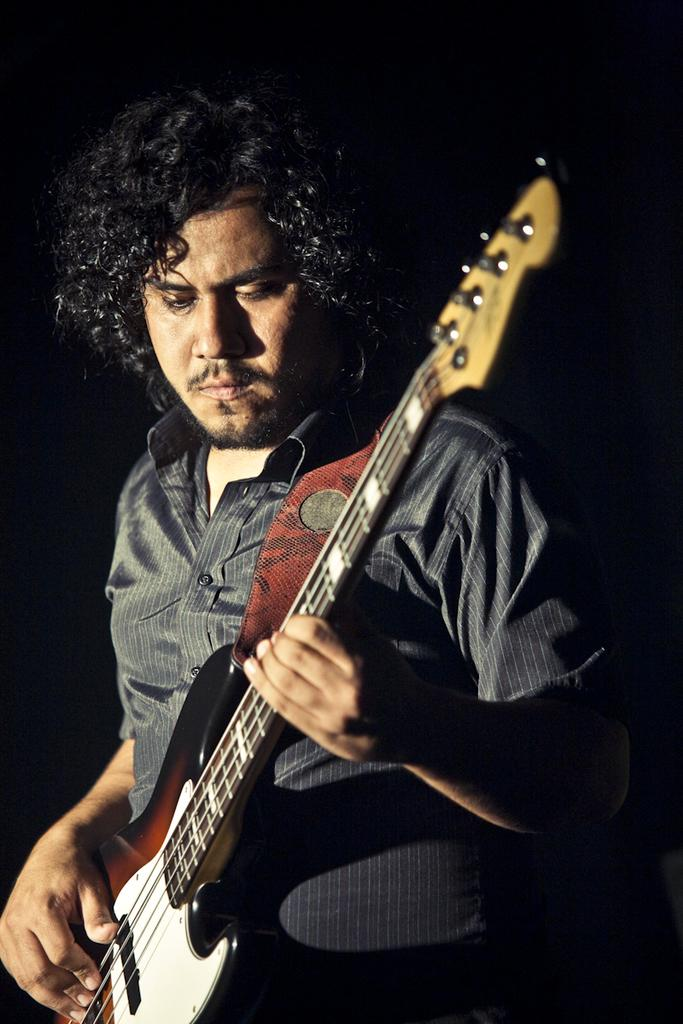What is the main subject of the image? The main subject of the image is a man. What is the man holding in the image? The man is holding a guitar. What is the man wearing in the image? The man is wearing a black shirt. Can you tell me how many clocks are visible in the image? There are no clocks visible in the image. What type of activity is the man performing at the seashore in the image? There is no seashore present in the image, and the man is not performing any activity. 